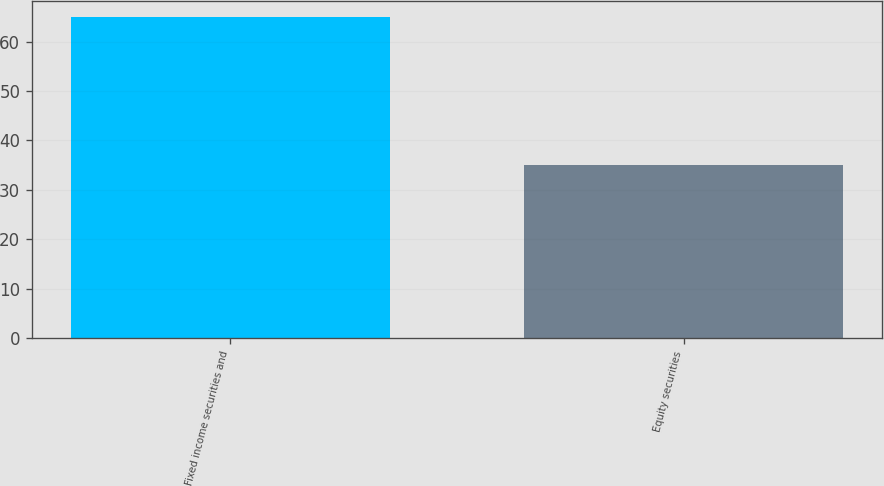<chart> <loc_0><loc_0><loc_500><loc_500><bar_chart><fcel>Fixed income securities and<fcel>Equity securities<nl><fcel>65<fcel>35<nl></chart> 